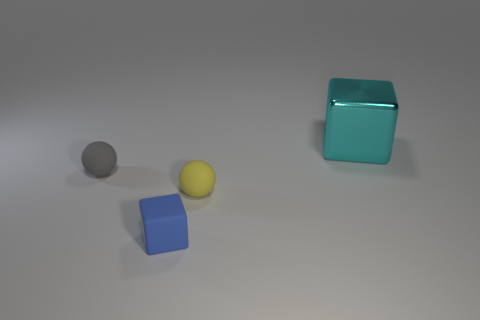The thing that is to the right of the tiny blue cube and behind the yellow ball has what shape?
Your answer should be very brief. Cube. Are there the same number of cyan blocks in front of the cyan metallic cube and yellow matte things behind the tiny gray thing?
Your response must be concise. Yes. What number of blocks are either small blue objects or cyan things?
Your response must be concise. 2. How many other big blocks have the same material as the big cyan cube?
Provide a succinct answer. 0. What is the thing that is behind the tiny yellow sphere and to the right of the gray sphere made of?
Make the answer very short. Metal. What is the shape of the rubber object to the right of the small blue block?
Provide a short and direct response. Sphere. What shape is the small matte object that is on the right side of the tiny thing in front of the yellow rubber object?
Your answer should be very brief. Sphere. Are there any other big things that have the same shape as the blue matte object?
Your answer should be very brief. Yes. The gray thing that is the same size as the blue matte object is what shape?
Keep it short and to the point. Sphere. Are there any things that are on the left side of the object that is behind the small ball left of the blue object?
Make the answer very short. Yes. 